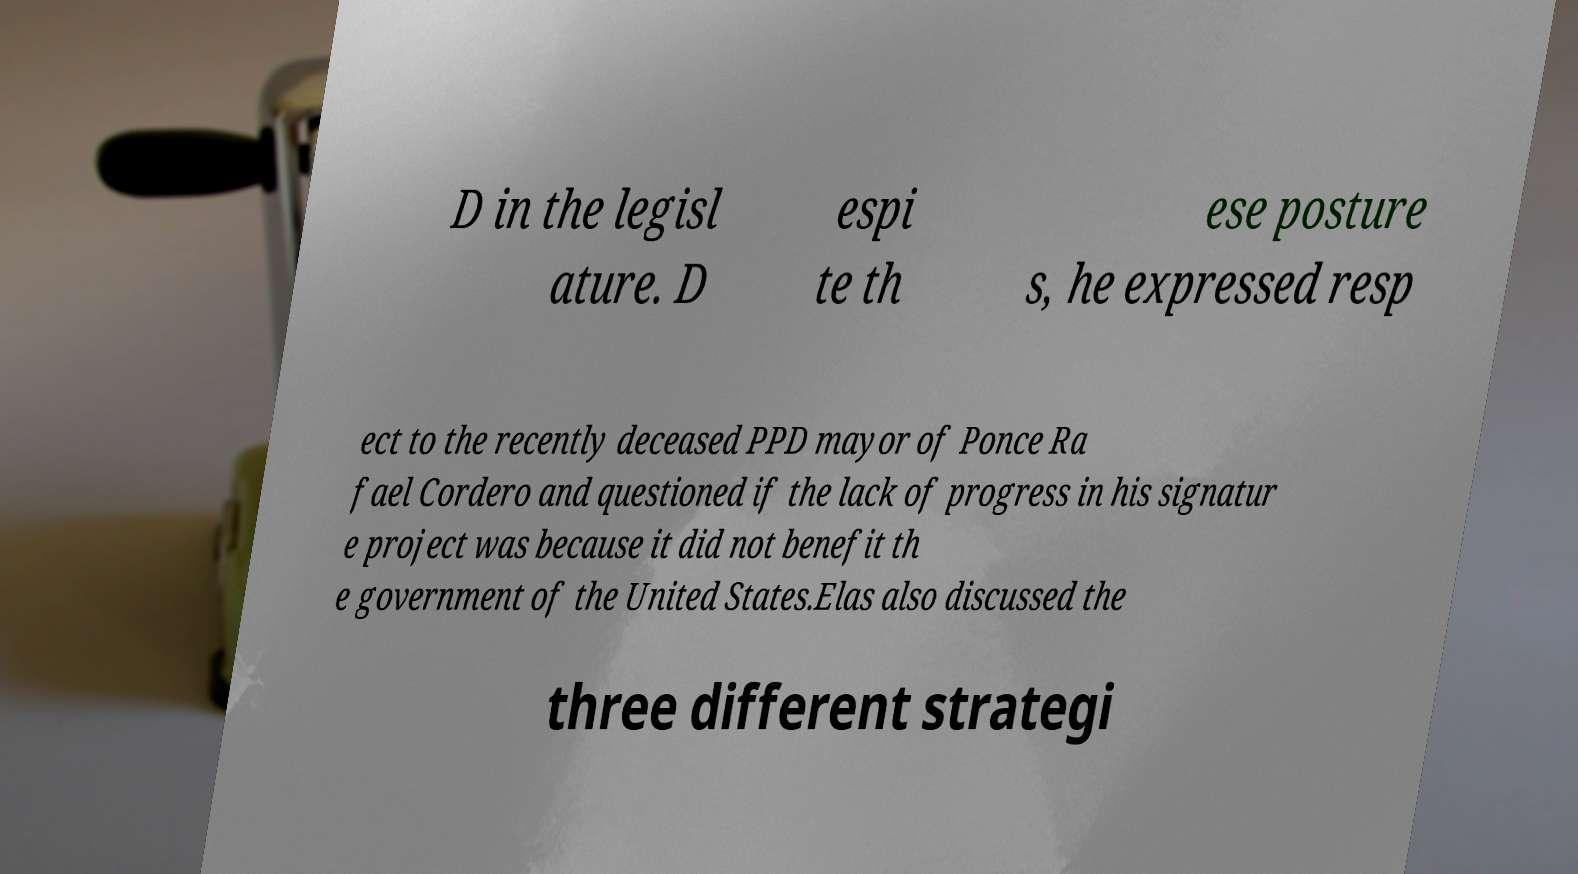Can you read and provide the text displayed in the image?This photo seems to have some interesting text. Can you extract and type it out for me? D in the legisl ature. D espi te th ese posture s, he expressed resp ect to the recently deceased PPD mayor of Ponce Ra fael Cordero and questioned if the lack of progress in his signatur e project was because it did not benefit th e government of the United States.Elas also discussed the three different strategi 